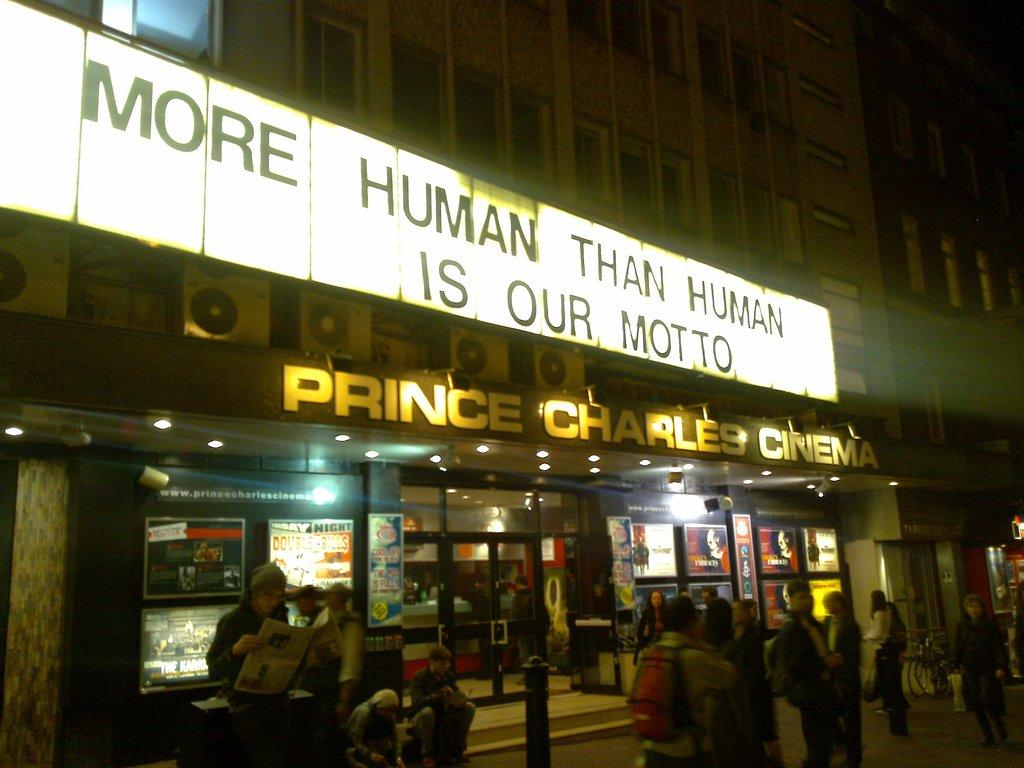<image>
Offer a succinct explanation of the picture presented. A sign that says More human than human is our motto 